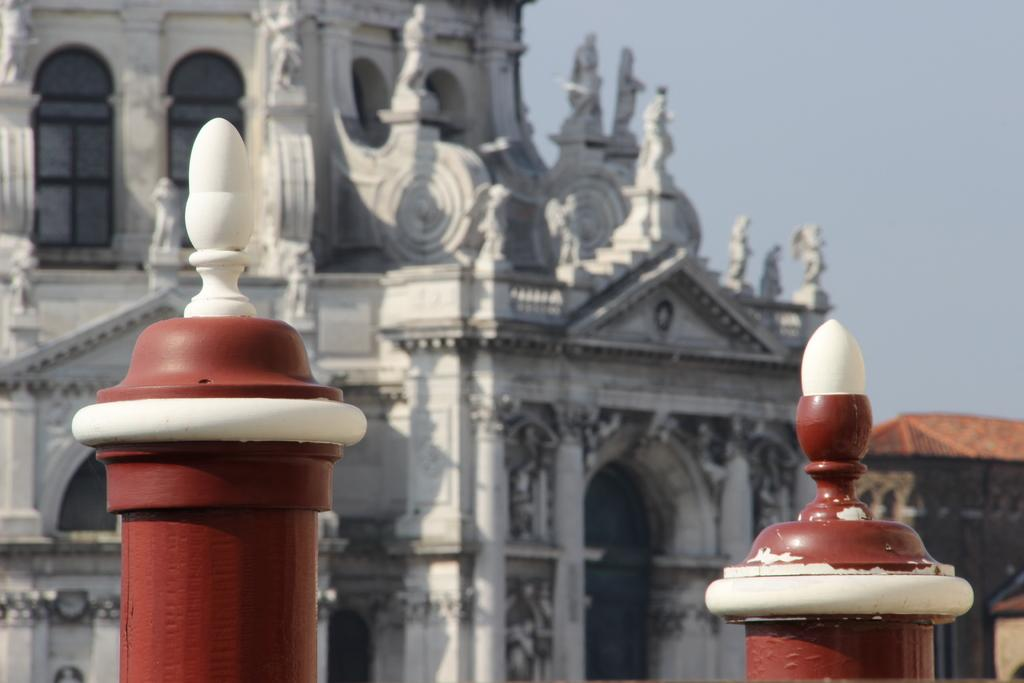What objects can be seen in the image that are supporting something? There are two poles in the image that support lights. What is attached to the poles in the image? Lights are fixed on the poles in the image. What can be seen in the background of the image? There is a beautiful architecture in the background of the image. What type of ink is being used to write on the slope in the image? There is no slope or ink present in the image. What is the army doing in the image? There is no army or related activity depicted in the image. 